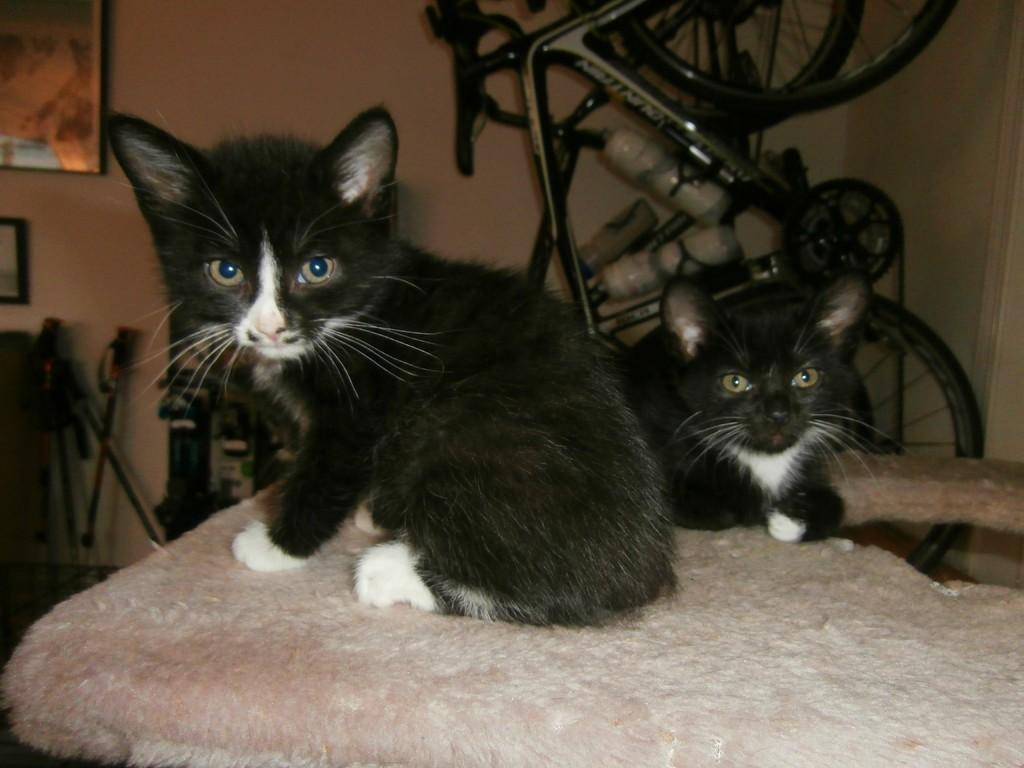What animals are on the blanket in the image? There are cats on a blanket in the image. What type of transportation is visible in the image? There are bicycles in the image. What objects can be seen in the image that are used for support or guidance? There are sticks in the image. What items are placed aside in the image? There are objects placed aside in the image. What type of decorative items are on the wall in the image? There are frames on a wall in the image. What type of wool is being used to make the zebra's fur in the image? There is no zebra present in the image, so there is no wool being used for its fur. How many birds are flying in the image? There are no birds visible in the image. 